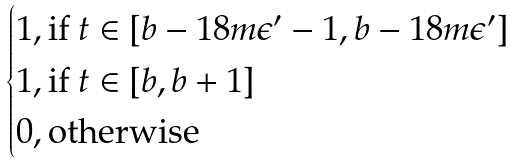Convert formula to latex. <formula><loc_0><loc_0><loc_500><loc_500>\begin{cases} 1 , \text {if } t \in [ b - 1 8 m \epsilon ^ { \prime } - 1 , b - 1 8 m \epsilon ^ { \prime } ] \\ 1 , \text {if } t \in [ b , b + 1 ] \\ 0 , \text {otherwise} \end{cases}</formula> 